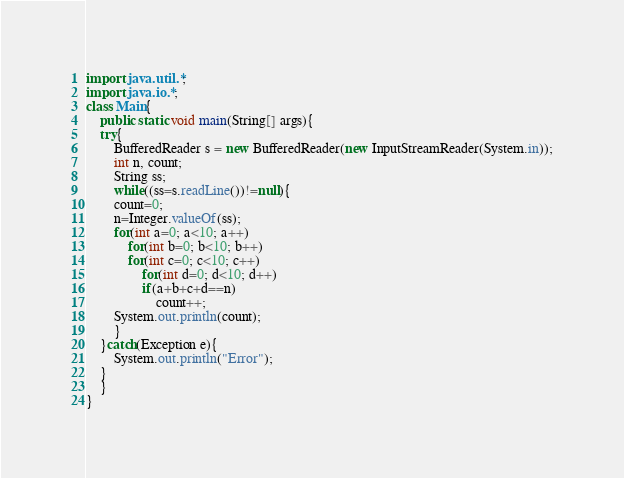<code> <loc_0><loc_0><loc_500><loc_500><_Java_>import java.util.*;
import java.io.*;
class Main{
    public static void main(String[] args){
	try{
	    BufferedReader s = new BufferedReader(new InputStreamReader(System.in));
	    int n, count;
	    String ss;
	    while((ss=s.readLine())!=null){
		count=0;
		n=Integer.valueOf(ss);
		for(int a=0; a<10; a++)
		    for(int b=0; b<10; b++)
			for(int c=0; c<10; c++)
			    for(int d=0; d<10; d++)
				if(a+b+c+d==n)
				    count++;
		System.out.println(count);
	    }
	}catch(Exception e){
	    System.out.println("Error");
	}
    }
}</code> 